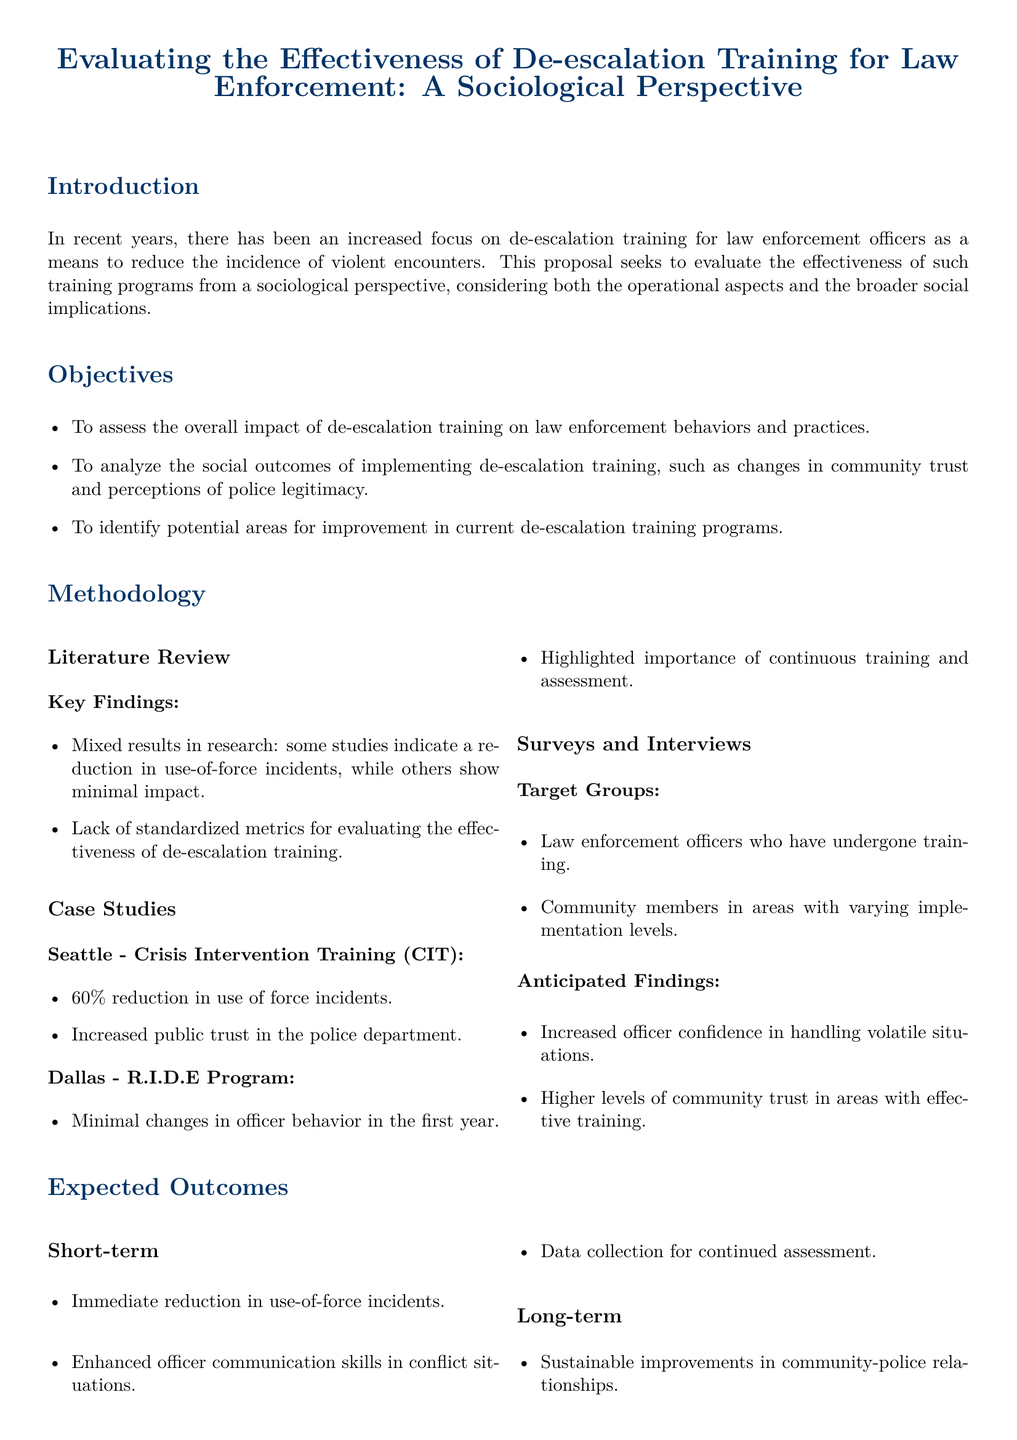what is the title of the proposal? The title of the proposal is mentioned in the header of the document.
Answer: Evaluating the Effectiveness of De-escalation Training for Law Enforcement: A Sociological Perspective what does the proposal aim to assess? The proposal aims to assess the impact of de-escalation training on behaviors and practices in law enforcement.
Answer: The overall impact of de-escalation training on law enforcement behaviors and practices how many case studies are mentioned in the methodology section? The methodology section lists specific case studies that are used to illustrate the research.
Answer: Two what was the reduction in use of force incidents reported in Seattle's Crisis Intervention Training? The document states specific statistics regarding the effectiveness of the training programs in different locations.
Answer: 60% which program showed minimal changes in officer behavior in the first year? The assessment of case studies highlights both successful and less successful training approaches.
Answer: R.I.D.E Program what is an anticipated finding from surveys and interviews? The document outlines key anticipated outcomes based on the target groups surveyed.
Answer: Increased officer confidence in handling volatile situations what is a short-term expected outcome of the proposed evaluation? Short-term outcomes are outlined that reflect immediate benefits of the training.
Answer: Immediate reduction in use-of-force incidents what is a long-term expected outcome related to community-police relationships? The document discusses goals that focus on sustainable benefits beyond immediate outcomes.
Answer: Sustainable improvements in community-police relationships what does the proposal seek to identify in current de-escalation training programs? The objectives section specifically mentions goals related to the analysis of training programs.
Answer: Potential areas for improvement 